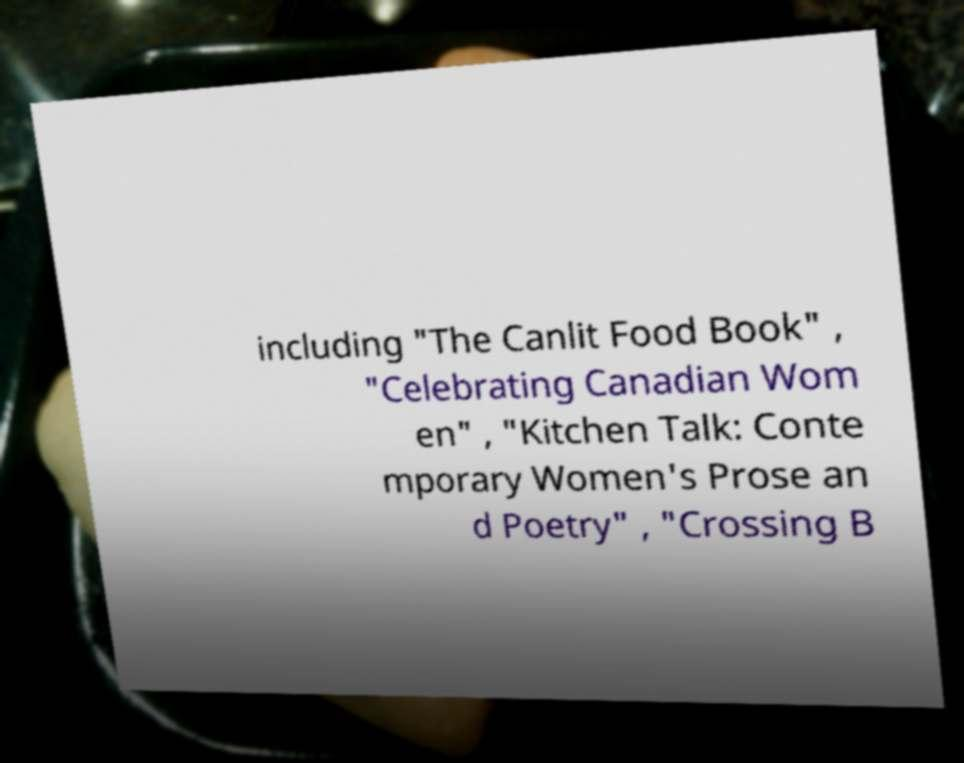Please identify and transcribe the text found in this image. including "The Canlit Food Book" , "Celebrating Canadian Wom en" , "Kitchen Talk: Conte mporary Women's Prose an d Poetry" , "Crossing B 